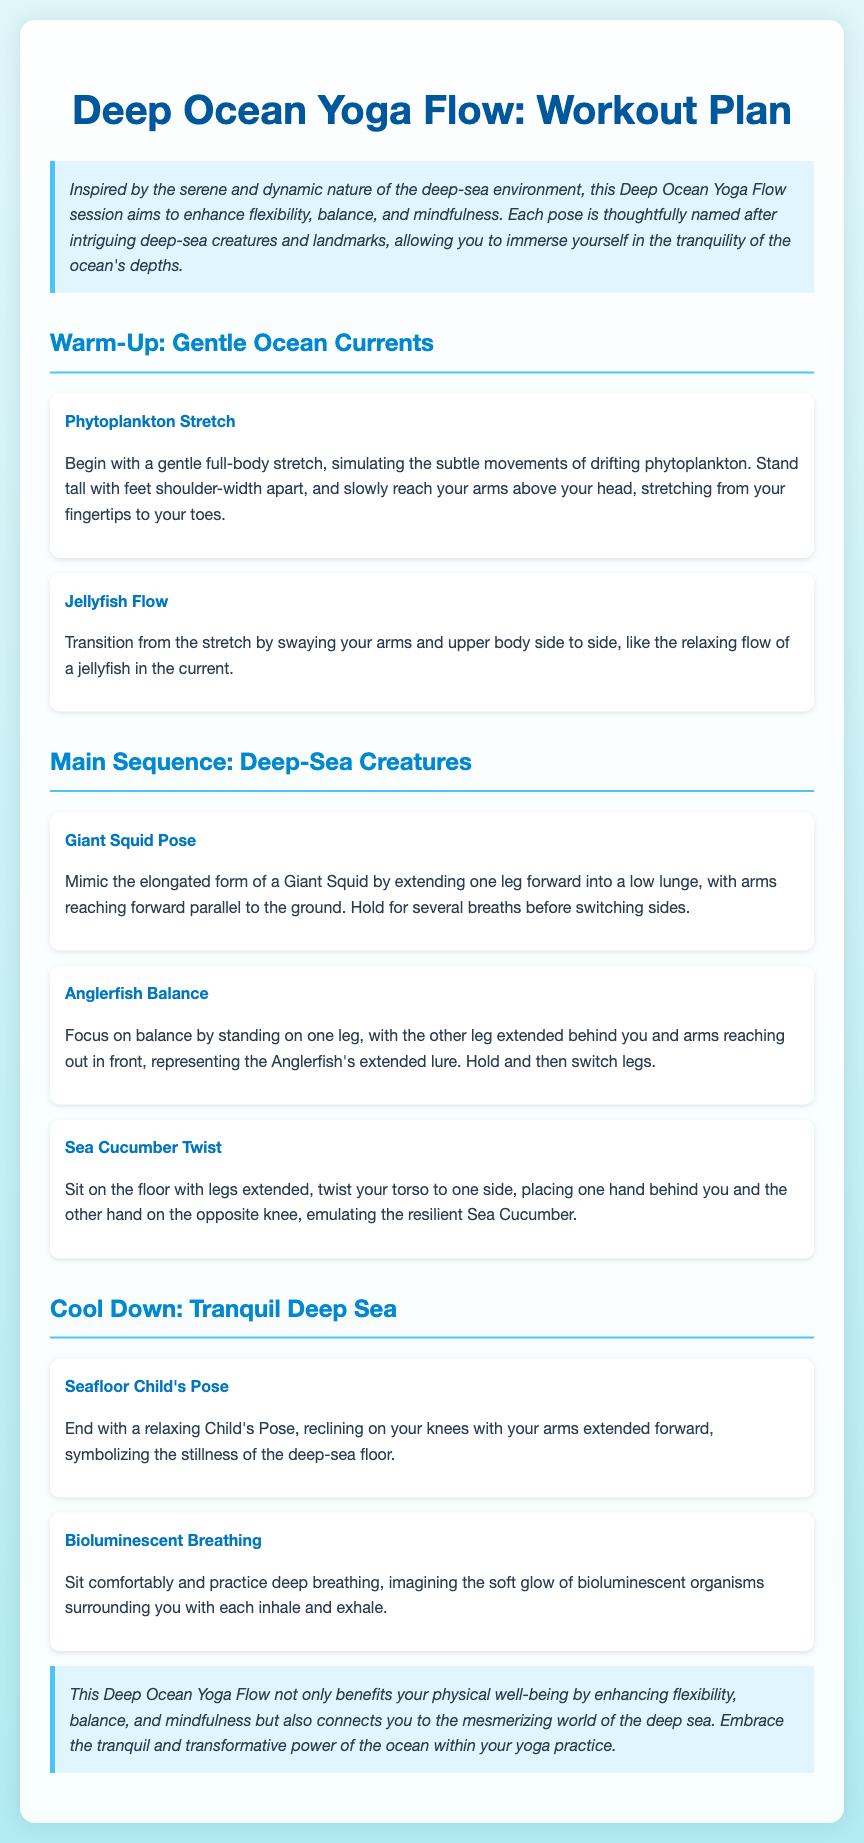what is the title of the document? The title of the document is stated at the top of the rendered content, which is "Deep Ocean Yoga Flow: Workout Plan."
Answer: Deep Ocean Yoga Flow: Workout Plan how many warm-up poses are included? The number of warm-up poses can be found in the section specifically mentioning warm-up poses. There are two listed: "Phytoplankton Stretch" and "Jellyfish Flow."
Answer: 2 what is the name of the first main sequence pose? The first main sequence pose is listed under the "Main Sequence: Deep-Sea Creatures" section, which is "Giant Squid Pose."
Answer: Giant Squid Pose what is the focus of the "Anglerfish Balance" pose? The focus of this pose relates to balance, as indicated in the description of the pose.
Answer: Balance how does the yoga session aim to benefit practitioners? The document states that the session enhances flexibility, balance, and mindfulness as benefits for practitioners.
Answer: Flexibility, balance, mindfulness what does "Bioluminescent Breathing" represent? This pose represents the soft glow of bioluminescent organisms, as indicated in its description.
Answer: Soft glow of bioluminescent organisms how many poses are in the cool down section? The cool down section includes two poses, "Seafloor Child's Pose" and "Bioluminescent Breathing."
Answer: 2 what does the introduction emphasize about the yoga session? The introduction emphasizes the session's inspiration drawn from the deep-sea environment and its aim to enhance specific physical skills.
Answer: Enhancing flexibility, balance, and mindfulness 